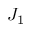Convert formula to latex. <formula><loc_0><loc_0><loc_500><loc_500>J _ { 1 }</formula> 